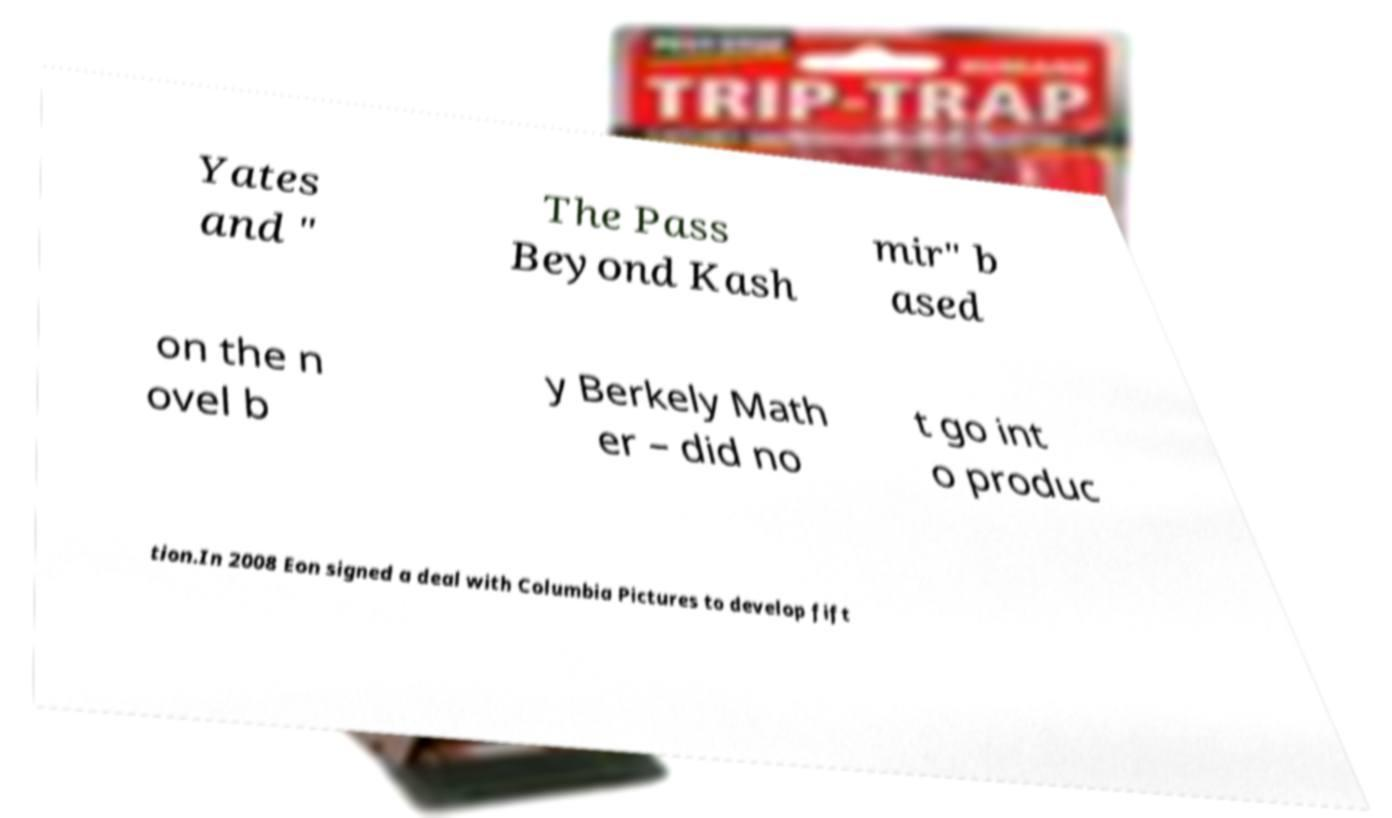Can you accurately transcribe the text from the provided image for me? Yates and " The Pass Beyond Kash mir" b ased on the n ovel b y Berkely Math er – did no t go int o produc tion.In 2008 Eon signed a deal with Columbia Pictures to develop fift 